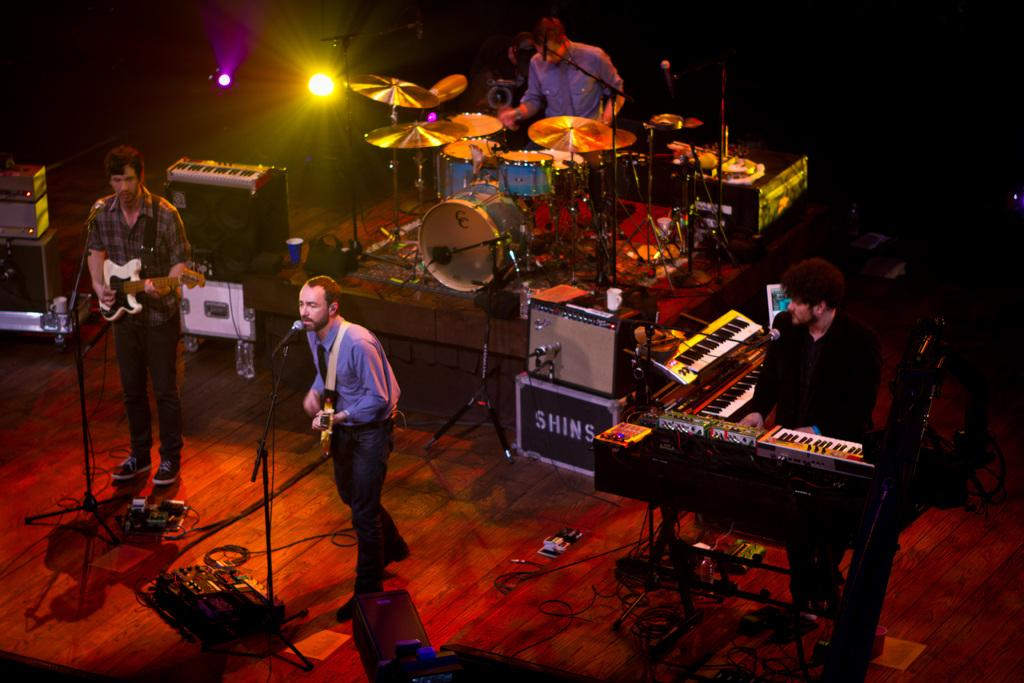What is happening on the stage in the image? There are people on the stage, and they are performing. What are the people doing while performing? They are playing musical instruments. Can you describe the lighting in the image? There is a light visible in the image. What type of engine can be seen powering the musical instruments in the image? There is no engine present in the image, and the musical instruments are not powered by an engine. 